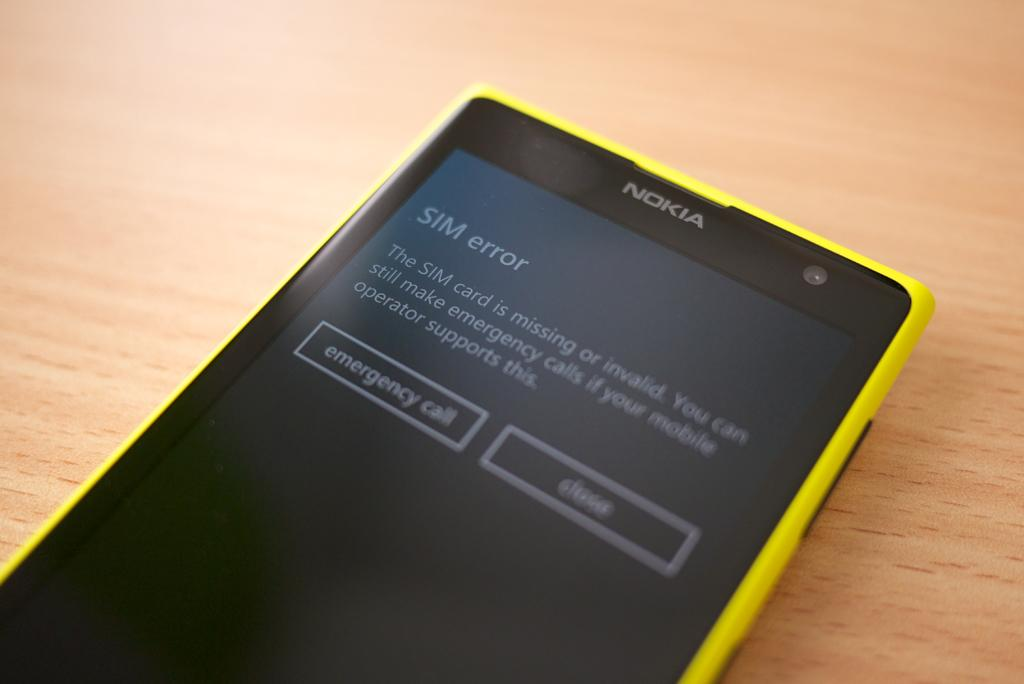<image>
Create a compact narrative representing the image presented. A yellow Nokia cell phone that shows a SIM error on the screen. 